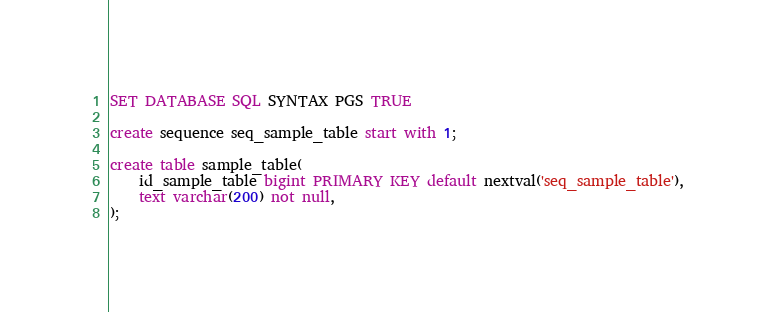Convert code to text. <code><loc_0><loc_0><loc_500><loc_500><_SQL_>SET DATABASE SQL SYNTAX PGS TRUE

create sequence seq_sample_table start with 1;

create table sample_table(
	id_sample_table bigint PRIMARY KEY default nextval('seq_sample_table'),
	text varchar(200) not null,
);</code> 